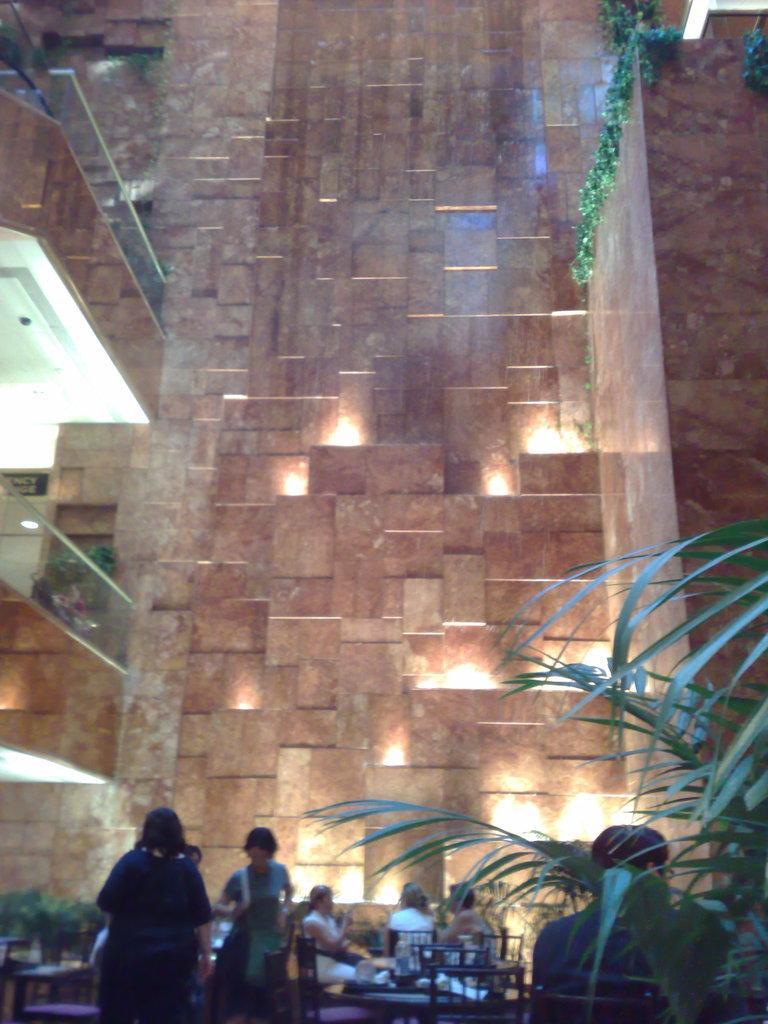In one or two sentences, can you explain what this image depicts? In the foreground, I can see chairs, tables, houseplants and a group of people on the floor. In the background, I can see buildings, lights and creepers. This image taken, maybe during night. 